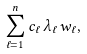<formula> <loc_0><loc_0><loc_500><loc_500>\sum _ { \ell = 1 } ^ { n } c _ { \ell } \, \lambda _ { \ell } \, w _ { \ell } ,</formula> 